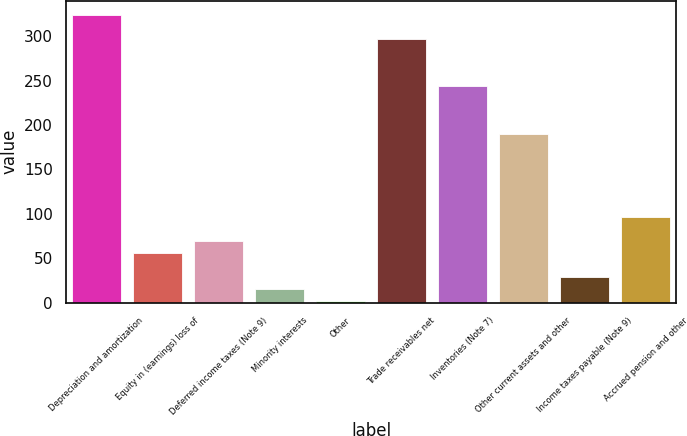Convert chart. <chart><loc_0><loc_0><loc_500><loc_500><bar_chart><fcel>Depreciation and amortization<fcel>Equity in (earnings) loss of<fcel>Deferred income taxes (Note 9)<fcel>Minority interests<fcel>Other<fcel>Trade receivables net<fcel>Inventories (Note 7)<fcel>Other current assets and other<fcel>Income taxes payable (Note 9)<fcel>Accrued pension and other<nl><fcel>323.66<fcel>55.86<fcel>69.25<fcel>15.69<fcel>2.3<fcel>296.88<fcel>243.32<fcel>189.76<fcel>29.08<fcel>96.03<nl></chart> 